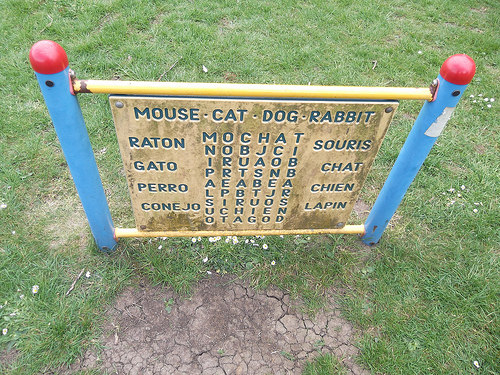<image>
Is the sign above the leaf? Yes. The sign is positioned above the leaf in the vertical space, higher up in the scene. 